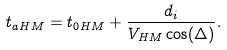Convert formula to latex. <formula><loc_0><loc_0><loc_500><loc_500>t _ { a H M } = t _ { 0 H M } + \frac { d _ { i } } { V _ { H M } \cos ( \Delta ) } .</formula> 